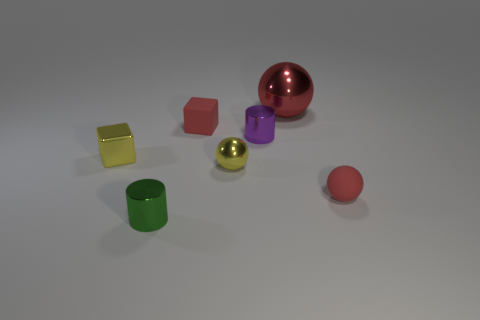Are there any other things that have the same size as the red shiny ball?
Ensure brevity in your answer.  No. There is another sphere that is the same material as the yellow sphere; what is its color?
Ensure brevity in your answer.  Red. Are the purple cylinder and the red sphere in front of the tiny shiny sphere made of the same material?
Provide a succinct answer. No. How many other small red cubes are the same material as the small red cube?
Ensure brevity in your answer.  0. There is a matte object that is behind the tiny metallic cube; what shape is it?
Offer a very short reply. Cube. Do the small cylinder that is in front of the tiny purple shiny thing and the yellow thing to the left of the red block have the same material?
Provide a short and direct response. Yes. Is there a small yellow thing that has the same shape as the large shiny thing?
Provide a succinct answer. Yes. How many things are balls behind the purple cylinder or green shiny cylinders?
Make the answer very short. 2. Are there more tiny metallic objects that are behind the green cylinder than red things in front of the red block?
Ensure brevity in your answer.  Yes. What number of matte things are either green cylinders or gray spheres?
Ensure brevity in your answer.  0. 